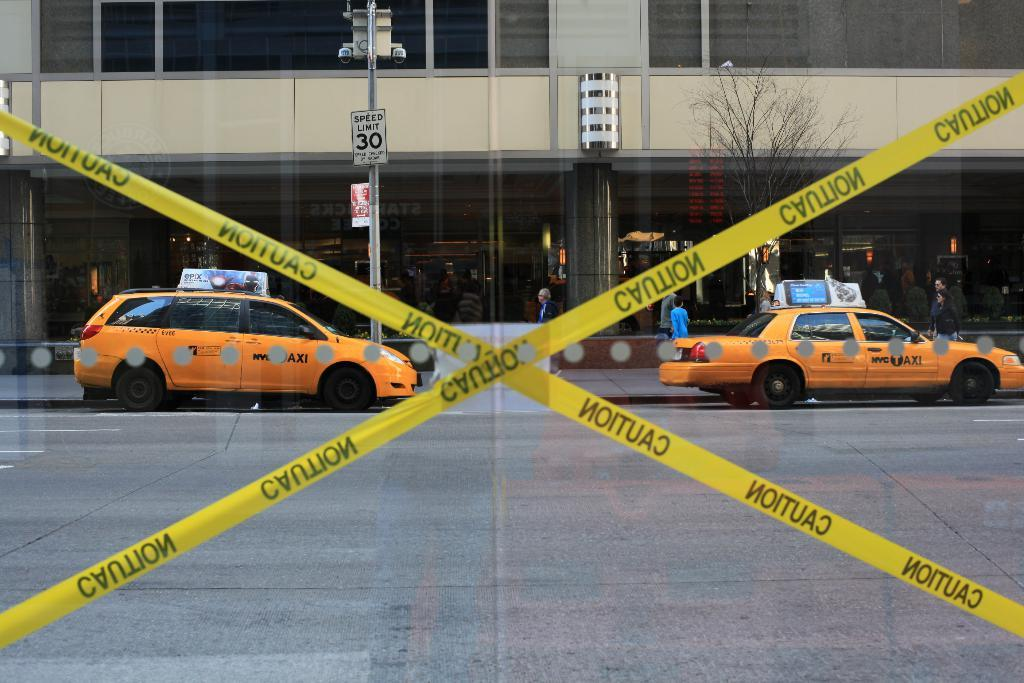<image>
Share a concise interpretation of the image provided. Caution tape blocks off an area in front of 2 orange cars and a building. 